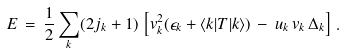Convert formula to latex. <formula><loc_0><loc_0><loc_500><loc_500>E \, = \, \frac { 1 } { 2 } \sum _ { k } ( 2 j _ { k } + 1 ) \, \left [ v _ { k } ^ { 2 } ( \epsilon _ { k } + \langle k | T | k \rangle ) \, - \, u _ { k } \, v _ { k } \, \Delta _ { k } \right ] \, .</formula> 